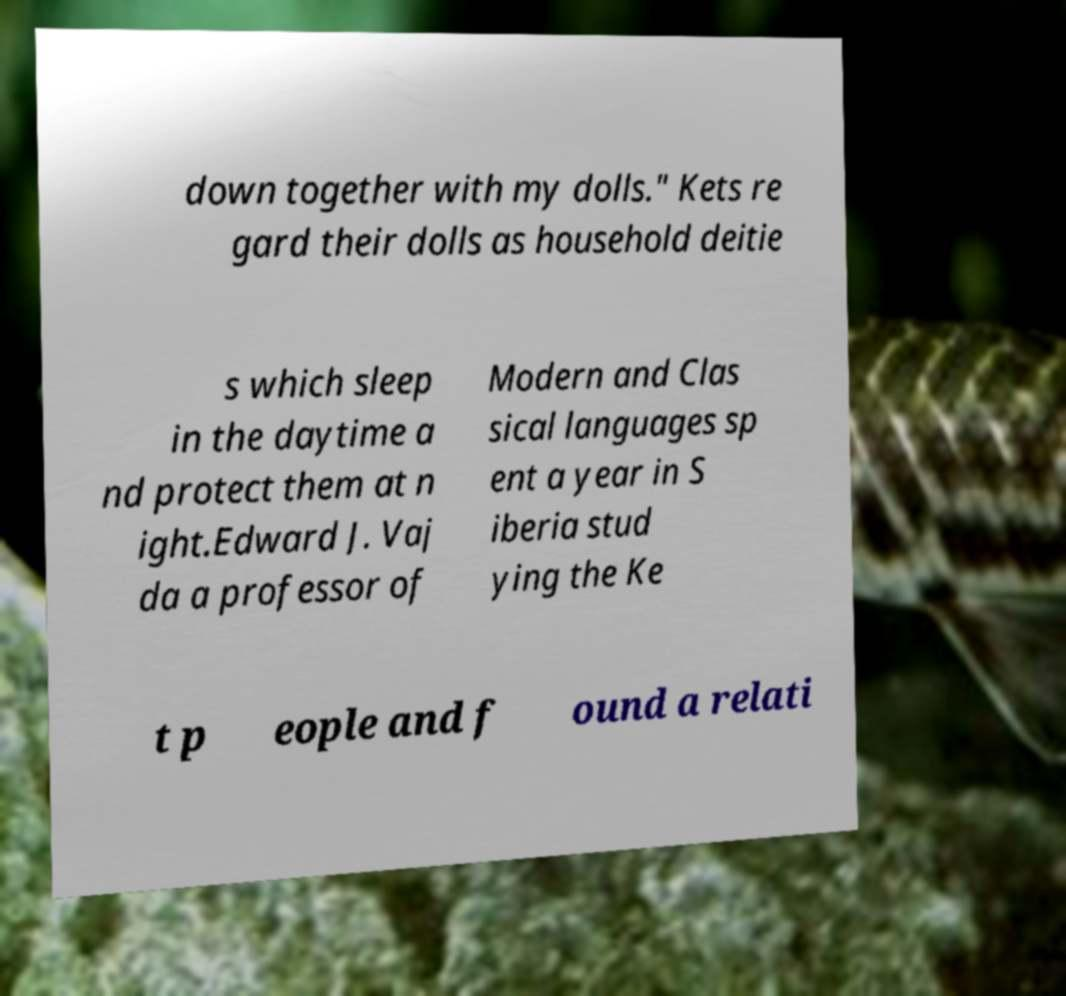Can you accurately transcribe the text from the provided image for me? down together with my dolls." Kets re gard their dolls as household deitie s which sleep in the daytime a nd protect them at n ight.Edward J. Vaj da a professor of Modern and Clas sical languages sp ent a year in S iberia stud ying the Ke t p eople and f ound a relati 